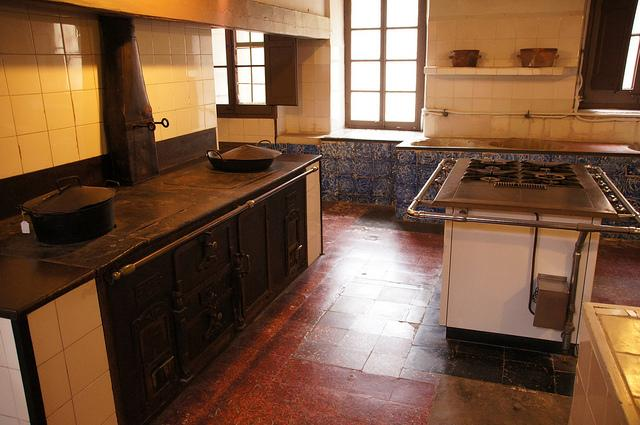Where would a kitchen like this be located?

Choices:
A) kitchenette
B) dorm room
C) restaurant
D) mountain cabin restaurant 